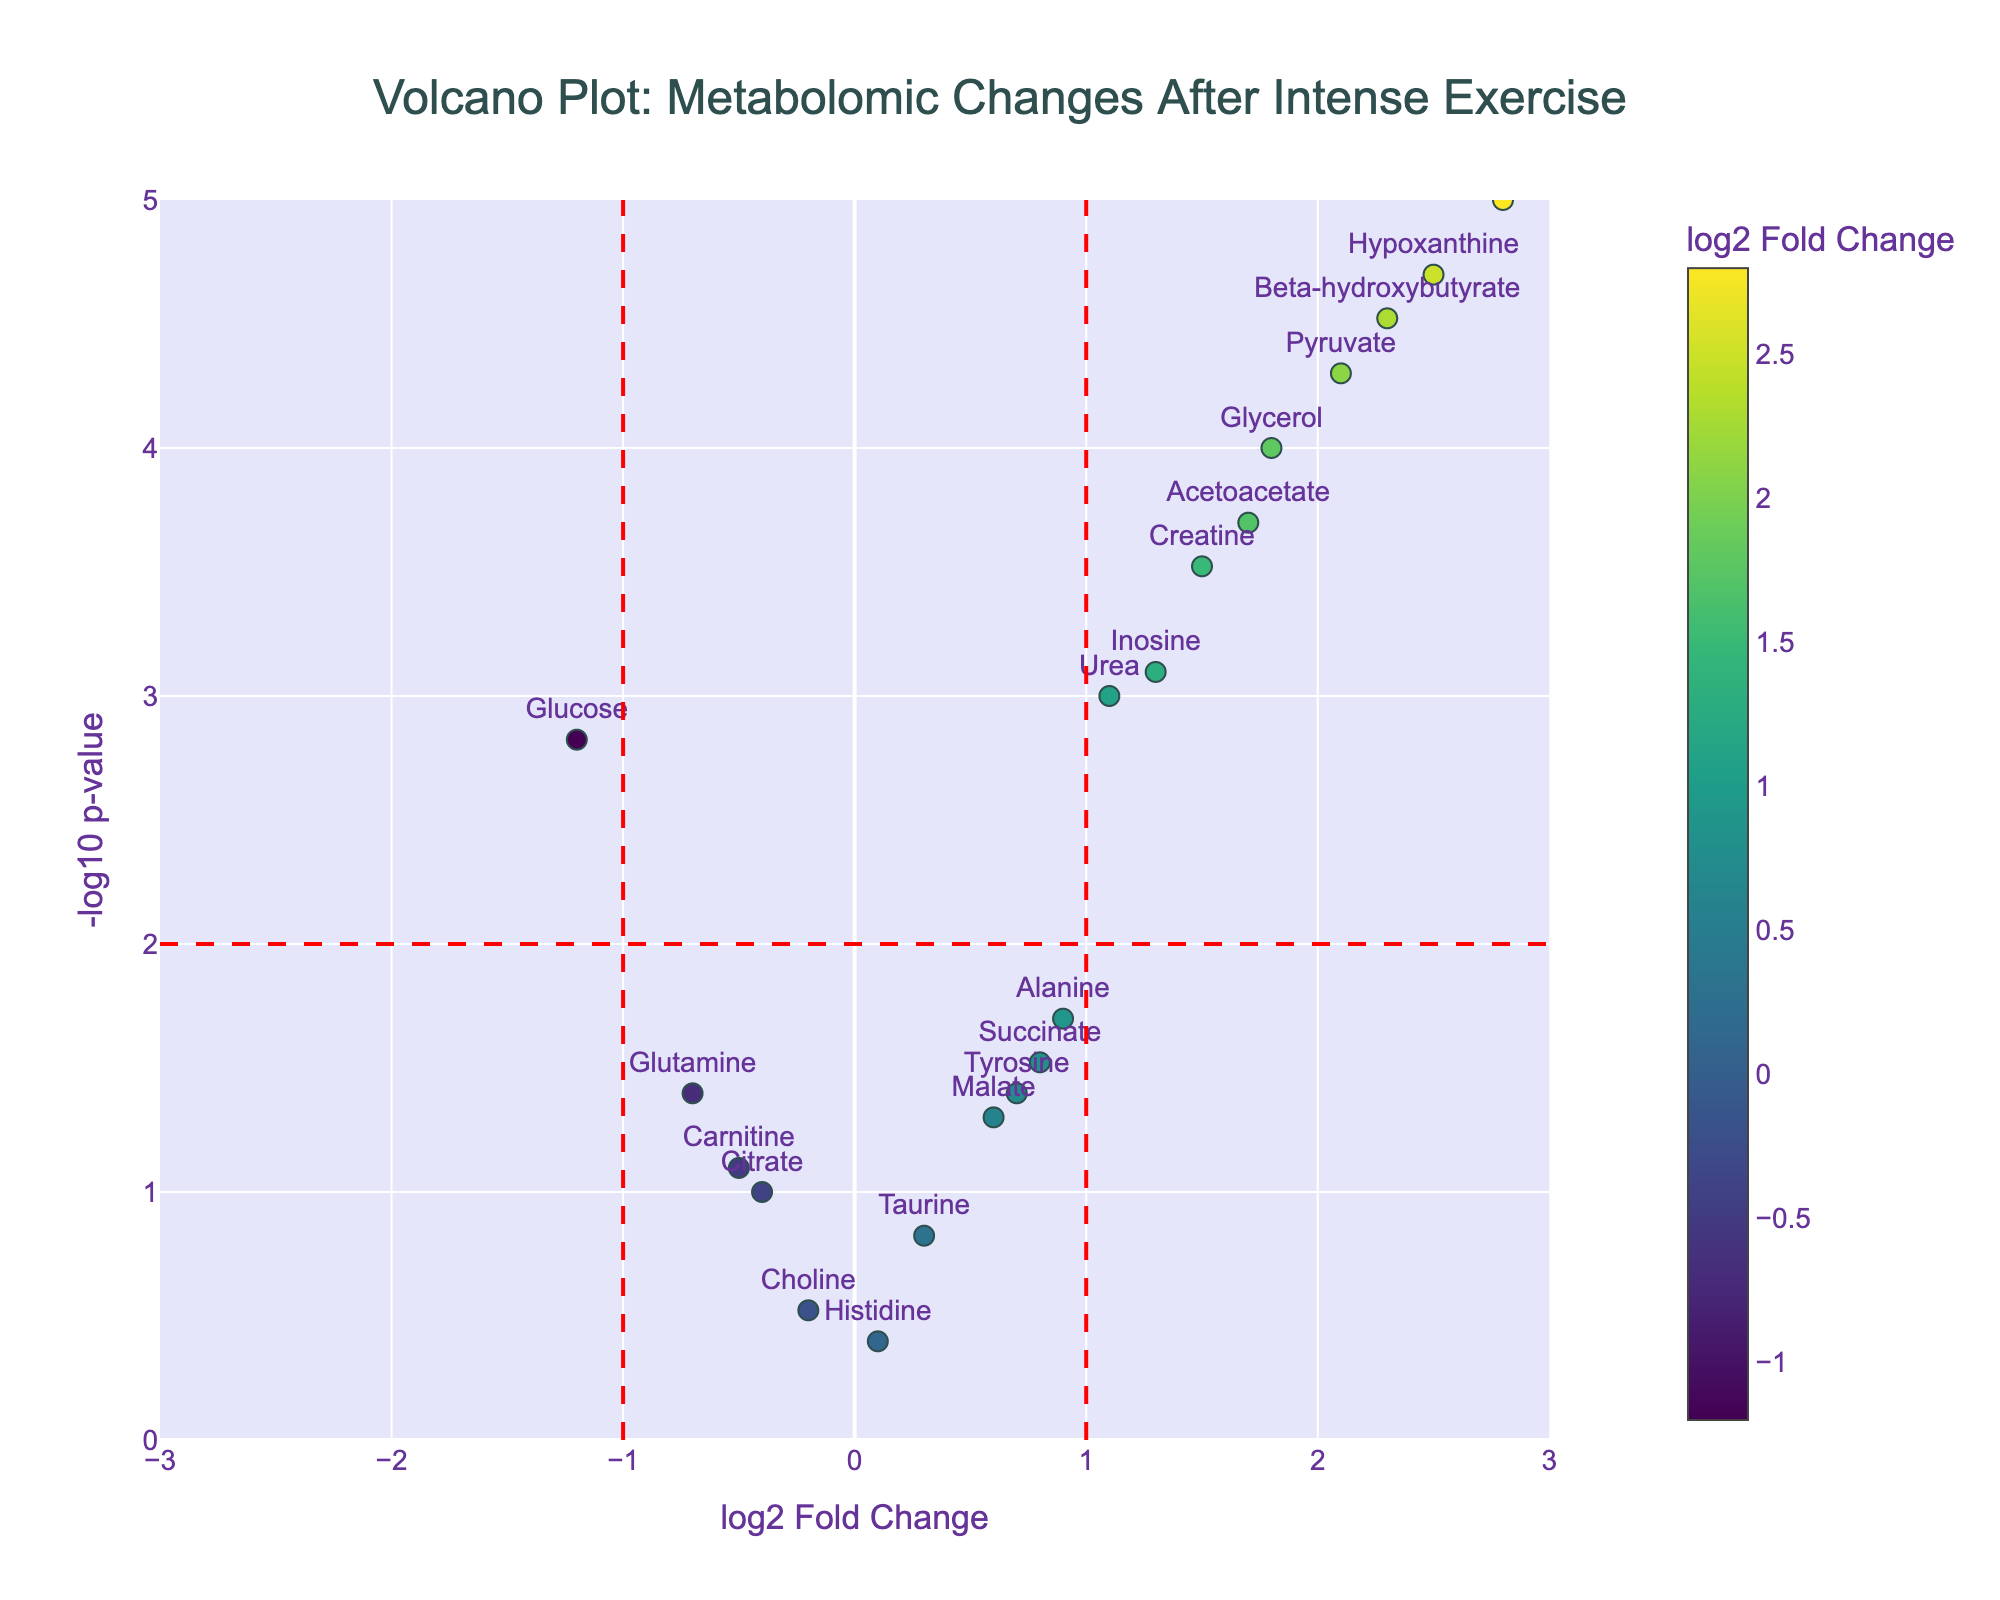What is the title of the figure? The title of the figure is prominently displayed at the top. In this case, it reads "Volcano Plot: Metabolomic Changes After Intense Exercise."
Answer: Volcano Plot: Metabolomic Changes After Intense Exercise What are the x-axis and y-axis titles in the Volcano Plot? The x-axis title is "log2 Fold Change" and the y-axis title is "-log10 p-value," as indicated below each axis.
Answer: log2 Fold Change; -log10 p-value Which metabolite has the highest log2 fold change? To find the metabolite with the highest log2 fold change, look at the x-axis values and identify the one farthest to the right. In this case, it is "Lactate" with a log2 fold change of 2.8.
Answer: Lactate Which metabolite has the smallest p-value? Smallest p-values correspond to the highest -log10(p-value) on the y-axis. "Lactate" and "Hypoxanthine" are the metabolites farthest up on the y-axis, with "Lactate" having the smallest p-value.
Answer: Lactate What is the -log10 p-value corresponding to a p-value of 0.0001? To convert a p-value to its -log10 value, take the negative logarithm (base 10) of the p-value. For a p-value of 0.0001: -log10(0.0001) = 4.
Answer: 4 Which metabolite has the lowest -log10 p-value while having a positive log2 fold change? Look for the lowest point on the y-axis above the x-axis (positive log2 fold change). "Alanine" at 0.9 log2 fold change and -log10 p-value around 1.7 fits this criterion.
Answer: Alanine How many metabolites have a log2 fold change greater than 1? Count the number of points to the right of 1 on the x-axis. Metabolites with a log2 fold change greater than 1 are "Lactate," "Creatine," "Pyruvate," "Glycerol," "Urea," "Inosine," "Hypoxanthine," "Acetoacetate," and "Beta-hydroxybutyrate." There are 9 such metabolites.
Answer: 9 Which metabolite has a log2 fold change closest to zero, and what is its p-value? Look at the x-axis for the point closest to zero and check its corresponding p-value. "Tyrosine" has a log2 fold change of 0.7 and the p-value associated with it is 0.04.
Answer: Tyrosine; 0.04 Identify a metabolite that has a log2 fold change of around 1.5 and significant p-value. Examine the metabolites near 1.5 on the x-axis and check their y-axis position (high -log10 p-value indicates significance). "Creatine" with a log2 fold change of 1.5 and a significant p-value of 0.0003 fits this criteria.
Answer: Creatine 